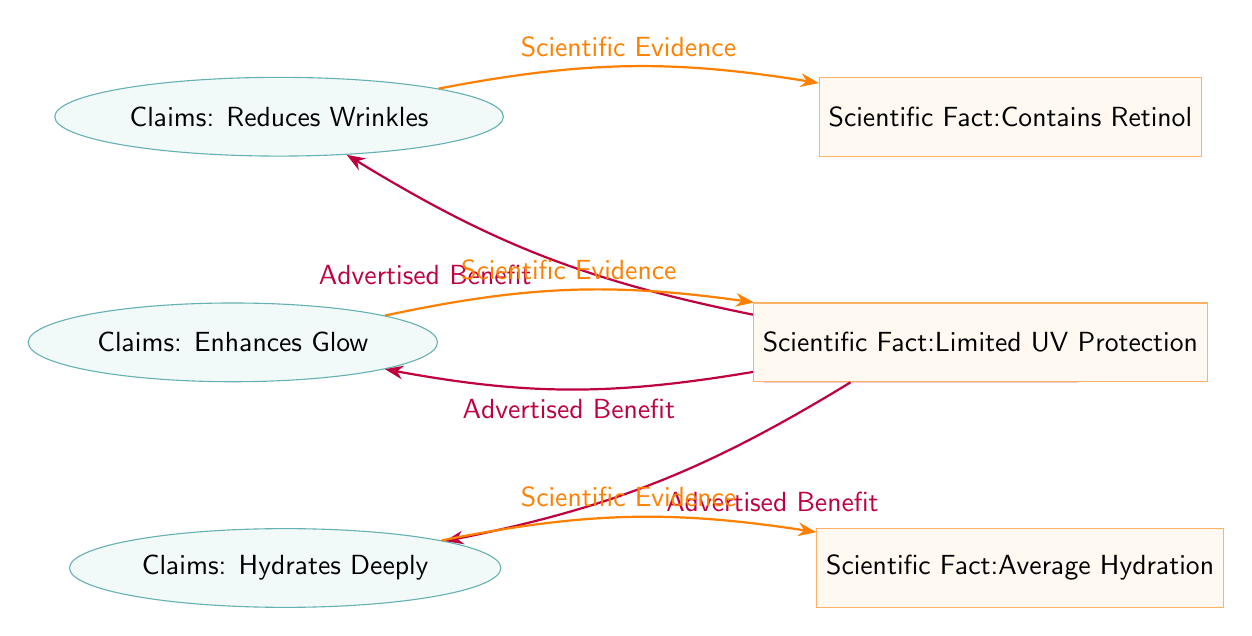What is the first claim listed in the diagram? The first claim listed in the diagram is "Reduces Wrinkles," which can be found in the upper left position pointing towards the celebrity endorsed product.
Answer: Reduces Wrinkles How many claims are associated with the celebrity endorsed product? There are three claims associated with the product, as indicated by the three ellipses on the left side of the diagram.
Answer: Three Which scientific fact is linked to the claim "Enhances Glow"? The scientific fact linked to "Enhances Glow" is "Limited UV Protection," which is directly to the right of that claim.
Answer: Limited UV Protection What is the relationship between "Claims: Hydrates Deeply" and its scientific evidence? The relationship is established through an arrow labeled "Scientific Evidence" that points from "Claims: Hydrates Deeply" to the corresponding scientific fact "Average Hydration."
Answer: Scientific Evidence Which product is the focus of the diagram? The focus of the diagram is "Celebrity Endorsed Product," which is centrally located in the diagram and connects to the claims and their corresponding scientific facts.
Answer: Celebrity Endorsed Product What color is used for the claims in the diagram? The claims are colored in teal, as represented by the filled ellipses of that color in the diagram.
Answer: Teal What is the scientific fact associated with the claim "Reduces Wrinkles"? The scientific fact associated with "Reduces Wrinkles" is "Contains Retinol," shown on the right of that claim with a corresponding arrow.
Answer: Contains Retinol How many arrows point to the claims from the celebrity endorsed product? There are three arrows pointing to the claims, each representing an advertised benefit from the product.
Answer: Three What type of shape is used to represent the scientific facts in the diagram? The scientific facts are represented by rectangles, specifically styled with orange colors.
Answer: Rectangles 